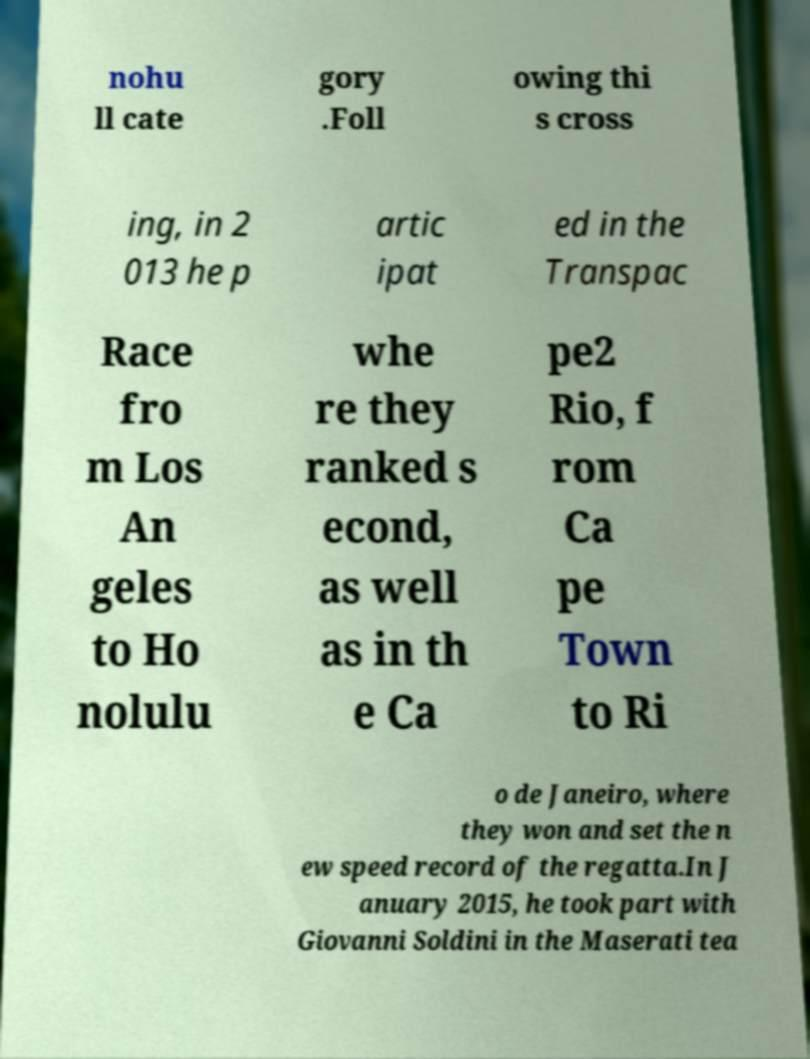Please read and relay the text visible in this image. What does it say? nohu ll cate gory .Foll owing thi s cross ing, in 2 013 he p artic ipat ed in the Transpac Race fro m Los An geles to Ho nolulu whe re they ranked s econd, as well as in th e Ca pe2 Rio, f rom Ca pe Town to Ri o de Janeiro, where they won and set the n ew speed record of the regatta.In J anuary 2015, he took part with Giovanni Soldini in the Maserati tea 